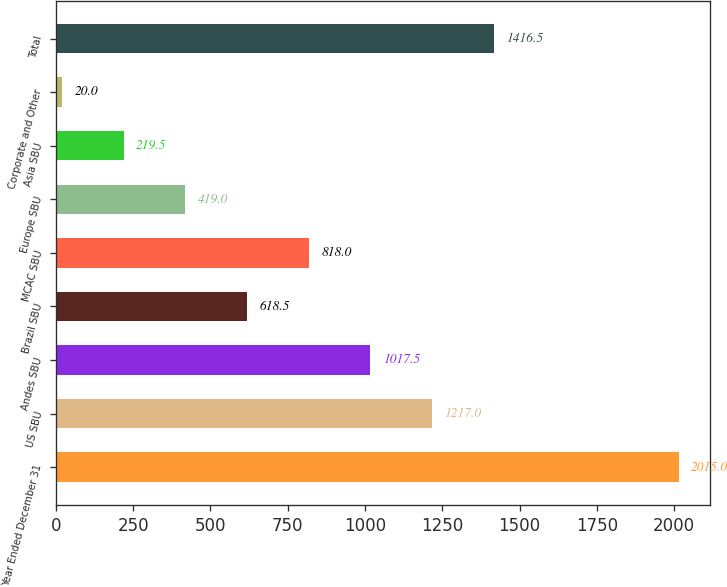Convert chart. <chart><loc_0><loc_0><loc_500><loc_500><bar_chart><fcel>Year Ended December 31<fcel>US SBU<fcel>Andes SBU<fcel>Brazil SBU<fcel>MCAC SBU<fcel>Europe SBU<fcel>Asia SBU<fcel>Corporate and Other<fcel>Total<nl><fcel>2015<fcel>1217<fcel>1017.5<fcel>618.5<fcel>818<fcel>419<fcel>219.5<fcel>20<fcel>1416.5<nl></chart> 